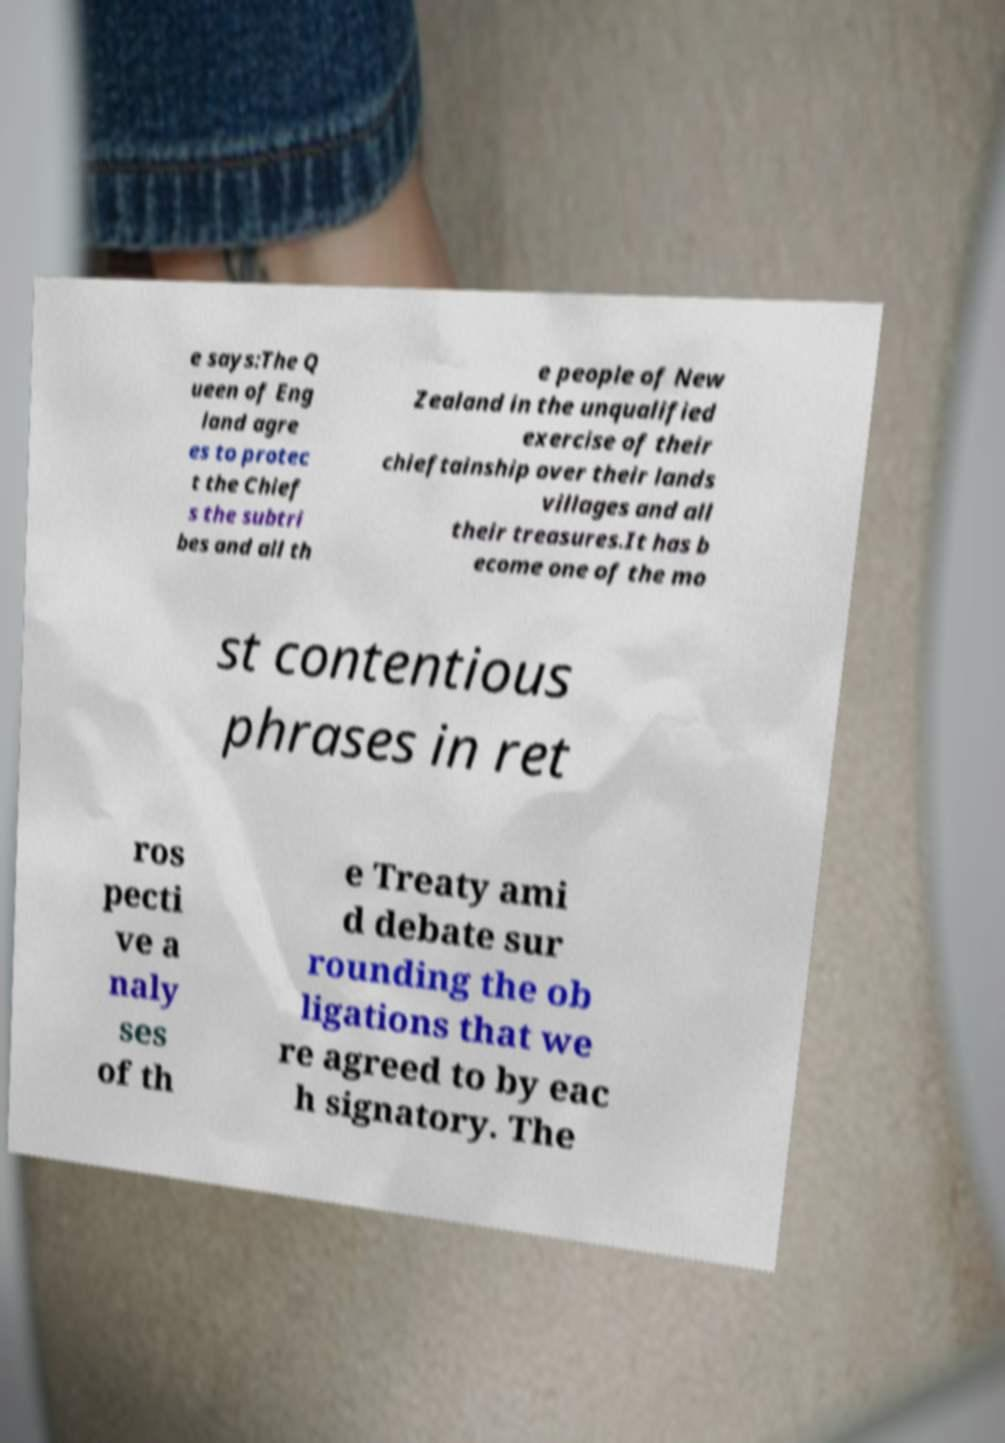Please read and relay the text visible in this image. What does it say? e says:The Q ueen of Eng land agre es to protec t the Chief s the subtri bes and all th e people of New Zealand in the unqualified exercise of their chieftainship over their lands villages and all their treasures.It has b ecome one of the mo st contentious phrases in ret ros pecti ve a naly ses of th e Treaty ami d debate sur rounding the ob ligations that we re agreed to by eac h signatory. The 